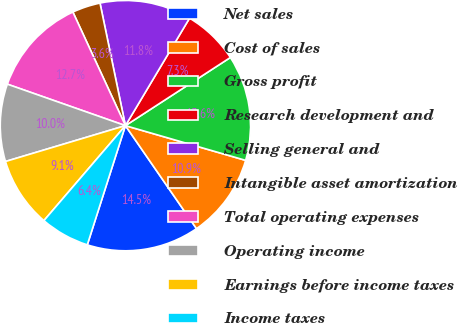Convert chart. <chart><loc_0><loc_0><loc_500><loc_500><pie_chart><fcel>Net sales<fcel>Cost of sales<fcel>Gross profit<fcel>Research development and<fcel>Selling general and<fcel>Intangible asset amortization<fcel>Total operating expenses<fcel>Operating income<fcel>Earnings before income taxes<fcel>Income taxes<nl><fcel>14.54%<fcel>10.91%<fcel>13.64%<fcel>7.27%<fcel>11.82%<fcel>3.64%<fcel>12.73%<fcel>10.0%<fcel>9.09%<fcel>6.36%<nl></chart> 